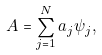<formula> <loc_0><loc_0><loc_500><loc_500>A = \sum _ { j = 1 } ^ { N } a _ { j } \psi _ { j } ,</formula> 